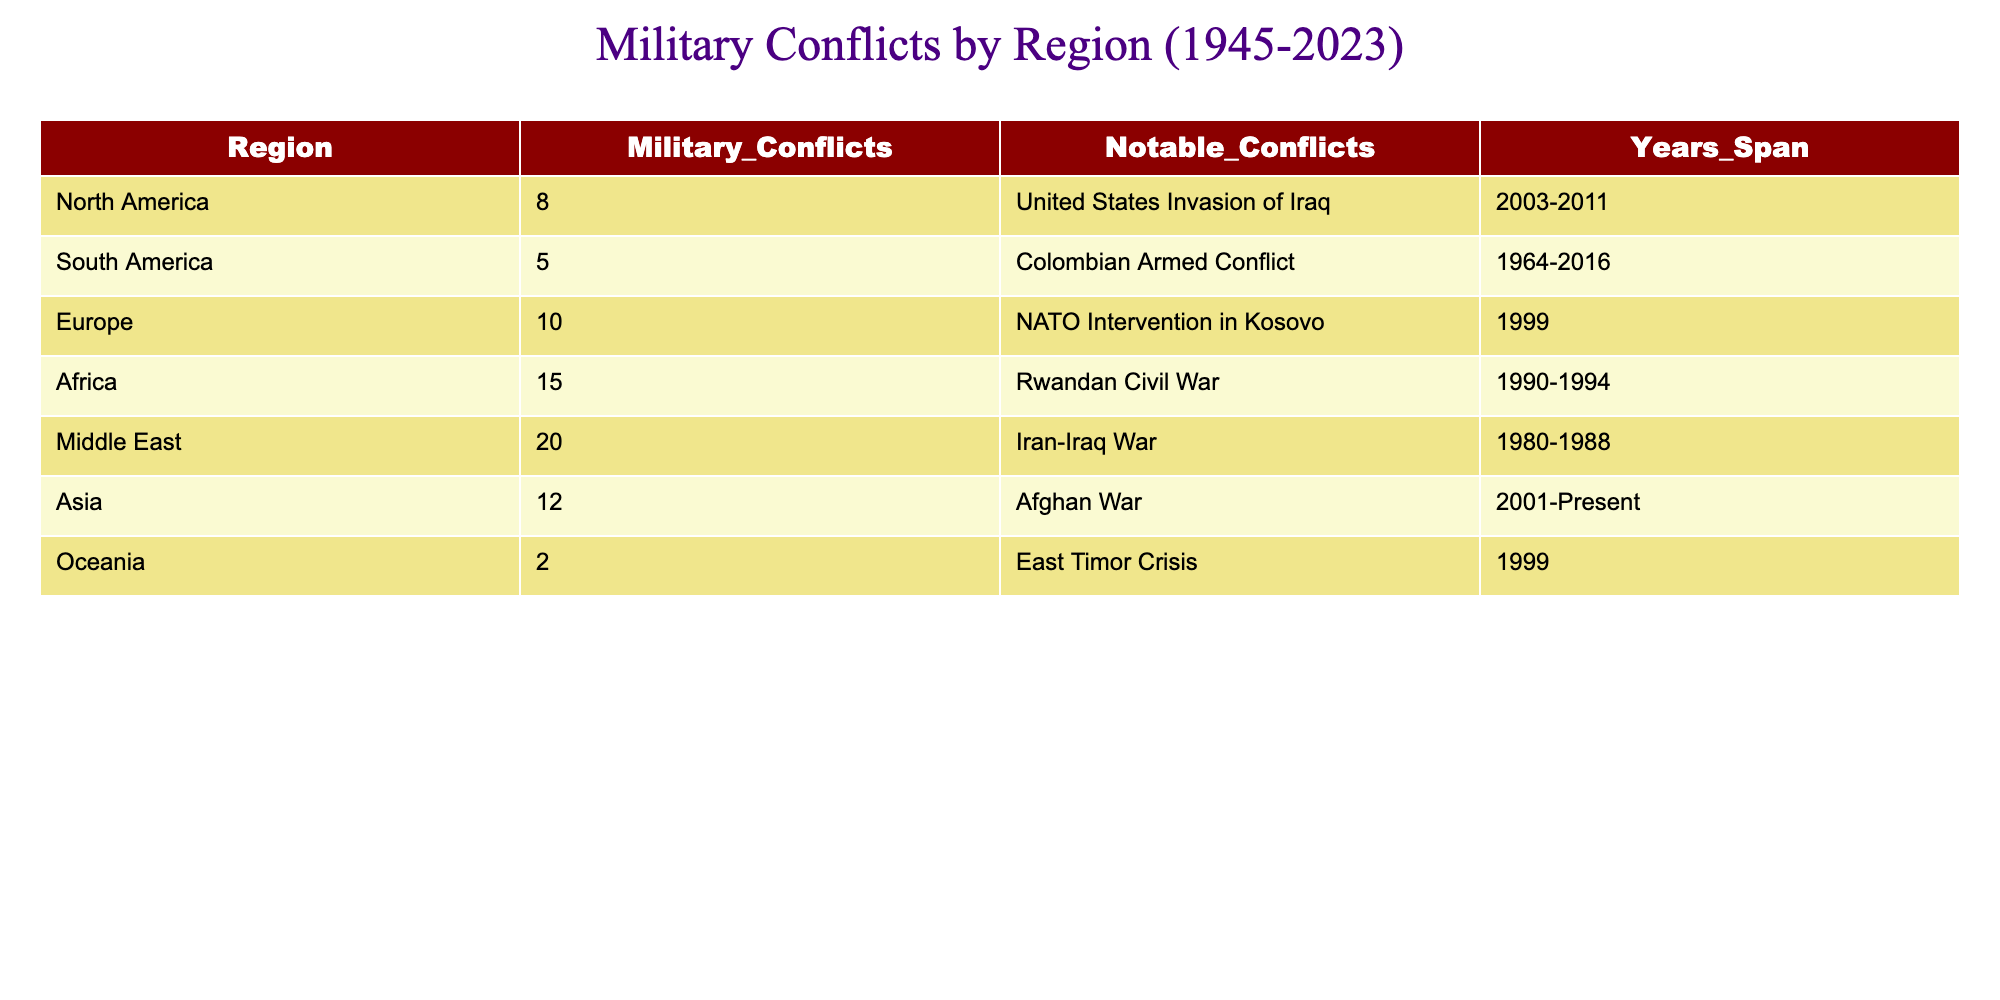What is the region with the highest number of military conflicts? From the table, the region with the highest military conflicts is the Middle East, which has 20 conflicts.
Answer: Middle East How many military conflicts does North America have? According to the table, North America has a total of 8 military conflicts listed.
Answer: 8 Which region had the notable conflict of the Rwandan Civil War? By checking the table, the Rwandan Civil War is noted under the Africa region.
Answer: Africa What is the total number of military conflicts in Asia and Europe combined? To find this, we add the military conflicts in Asia (12) and Europe (10): 12 + 10 = 22.
Answer: 22 Is the total number of military conflicts in Oceania greater than that in South America? The table shows Oceania with 2 conflicts and South America with 5 conflicts, meaning the statement is false as 2 is not greater than 5.
Answer: No What notable conflict is associated with the years 2001-Present? The table indicates that the Afghan War is associated with the years 2001-Present under the Asia region.
Answer: Afghan War Which region has the least number of military conflicts and how many are there? By reviewing the table, Oceania has the least military conflicts, with a total of 2 conflicts.
Answer: 2 What is the difference in the number of military conflicts between the Middle East and Africa? The difference is calculated by subtracting the conflicts in Africa (15) from those in the Middle East (20): 20 - 15 = 5.
Answer: 5 Which region experienced the Colombian Armed Conflict? The table states that the Colombian Armed Conflict is associated with South America.
Answer: South America 